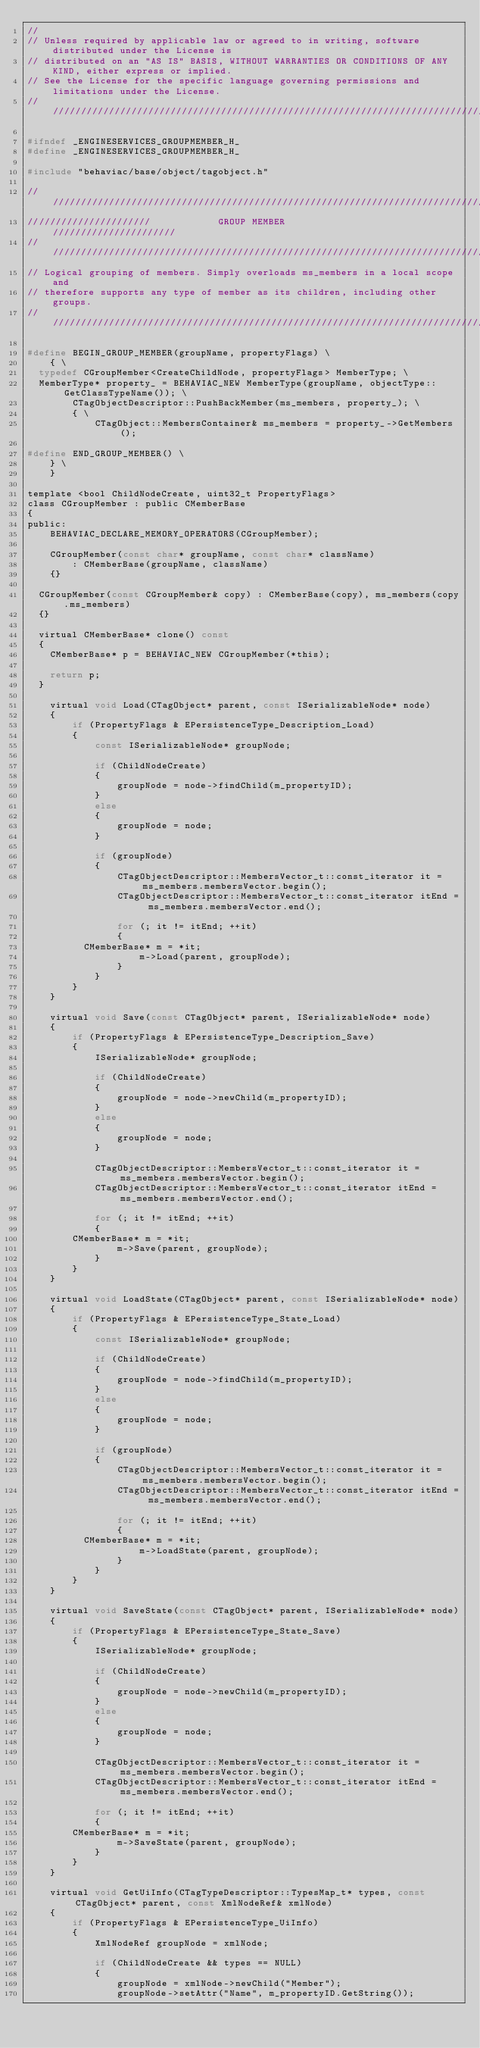Convert code to text. <code><loc_0><loc_0><loc_500><loc_500><_C_>//
// Unless required by applicable law or agreed to in writing, software distributed under the License is
// distributed on an "AS IS" BASIS, WITHOUT WARRANTIES OR CONDITIONS OF ANY KIND, either express or implied.
// See the License for the specific language governing permissions and limitations under the License.
/////////////////////////////////////////////////////////////////////////////////////////////////////////////////

#ifndef _ENGINESERVICES_GROUPMEMBER_H_
#define _ENGINESERVICES_GROUPMEMBER_H_

#include "behaviac/base/object/tagobject.h"

////////////////////////////////////////////////////////////////////////////////
//////////////////////            GROUP MEMBER            //////////////////////
////////////////////////////////////////////////////////////////////////////////
// Logical grouping of members. Simply overloads ms_members in a local scope and
// therefore supports any type of member as its children, including other groups.
////////////////////////////////////////////////////////////////////////////////

#define BEGIN_GROUP_MEMBER(groupName, propertyFlags) \
    { \
	typedef CGroupMember<CreateChildNode, propertyFlags> MemberType; \
	MemberType* property_ = BEHAVIAC_NEW MemberType(groupName, objectType::GetClassTypeName()); \
        CTagObjectDescriptor::PushBackMember(ms_members, property_); \
        { \
            CTagObject::MembersContainer& ms_members = property_->GetMembers();

#define END_GROUP_MEMBER() \
    } \
    }

template <bool ChildNodeCreate, uint32_t PropertyFlags>
class CGroupMember : public CMemberBase
{
public:
    BEHAVIAC_DECLARE_MEMORY_OPERATORS(CGroupMember);

    CGroupMember(const char* groupName, const char* className)
        : CMemberBase(groupName, className)
    {}

	CGroupMember(const CGroupMember& copy) : CMemberBase(copy), ms_members(copy.ms_members)
	{}

	virtual CMemberBase* clone() const
	{
		CMemberBase* p = BEHAVIAC_NEW CGroupMember(*this);

		return p;
	}

    virtual void Load(CTagObject* parent, const ISerializableNode* node)
    {
        if (PropertyFlags & EPersistenceType_Description_Load)
        {
            const ISerializableNode* groupNode;

            if (ChildNodeCreate)
            {
                groupNode = node->findChild(m_propertyID);
            }
            else
            {
                groupNode = node;
            }

            if (groupNode)
            {
                CTagObjectDescriptor::MembersVector_t::const_iterator it = ms_members.membersVector.begin();
                CTagObjectDescriptor::MembersVector_t::const_iterator itEnd = ms_members.membersVector.end();

                for (; it != itEnd; ++it)
                {
					CMemberBase* m = *it;
                    m->Load(parent, groupNode);
                }
            }
        }
    }

    virtual void Save(const CTagObject* parent, ISerializableNode* node)
    {
        if (PropertyFlags & EPersistenceType_Description_Save)
        {
            ISerializableNode* groupNode;

            if (ChildNodeCreate)
            {
                groupNode = node->newChild(m_propertyID);
            }
            else
            {
                groupNode = node;
            }

            CTagObjectDescriptor::MembersVector_t::const_iterator it = ms_members.membersVector.begin();
            CTagObjectDescriptor::MembersVector_t::const_iterator itEnd = ms_members.membersVector.end();

            for (; it != itEnd; ++it)
            {
				CMemberBase* m = *it;
                m->Save(parent, groupNode);
            }
        }
    }

    virtual void LoadState(CTagObject* parent, const ISerializableNode* node)
    {
        if (PropertyFlags & EPersistenceType_State_Load)
        {
            const ISerializableNode* groupNode;

            if (ChildNodeCreate)
            {
                groupNode = node->findChild(m_propertyID);
            }
            else
            {
                groupNode = node;
            }

            if (groupNode)
            {
                CTagObjectDescriptor::MembersVector_t::const_iterator it = ms_members.membersVector.begin();
                CTagObjectDescriptor::MembersVector_t::const_iterator itEnd = ms_members.membersVector.end();

                for (; it != itEnd; ++it)
                {
					CMemberBase* m = *it;
                    m->LoadState(parent, groupNode);
                }
            }
        }
    }

    virtual void SaveState(const CTagObject* parent, ISerializableNode* node)
    {
        if (PropertyFlags & EPersistenceType_State_Save)
        {
            ISerializableNode* groupNode;

            if (ChildNodeCreate)
            {
                groupNode = node->newChild(m_propertyID);
            }
            else
            {
                groupNode = node;
            }

            CTagObjectDescriptor::MembersVector_t::const_iterator it = ms_members.membersVector.begin();
            CTagObjectDescriptor::MembersVector_t::const_iterator itEnd = ms_members.membersVector.end();

            for (; it != itEnd; ++it)
            {
				CMemberBase* m = *it;
                m->SaveState(parent, groupNode);
            }
        }
    }

    virtual void GetUiInfo(CTagTypeDescriptor::TypesMap_t* types, const CTagObject* parent, const XmlNodeRef& xmlNode)
    {
        if (PropertyFlags & EPersistenceType_UiInfo)
        {
            XmlNodeRef groupNode = xmlNode;

            if (ChildNodeCreate && types == NULL)
            {
                groupNode = xmlNode->newChild("Member");
                groupNode->setAttr("Name", m_propertyID.GetString());</code> 